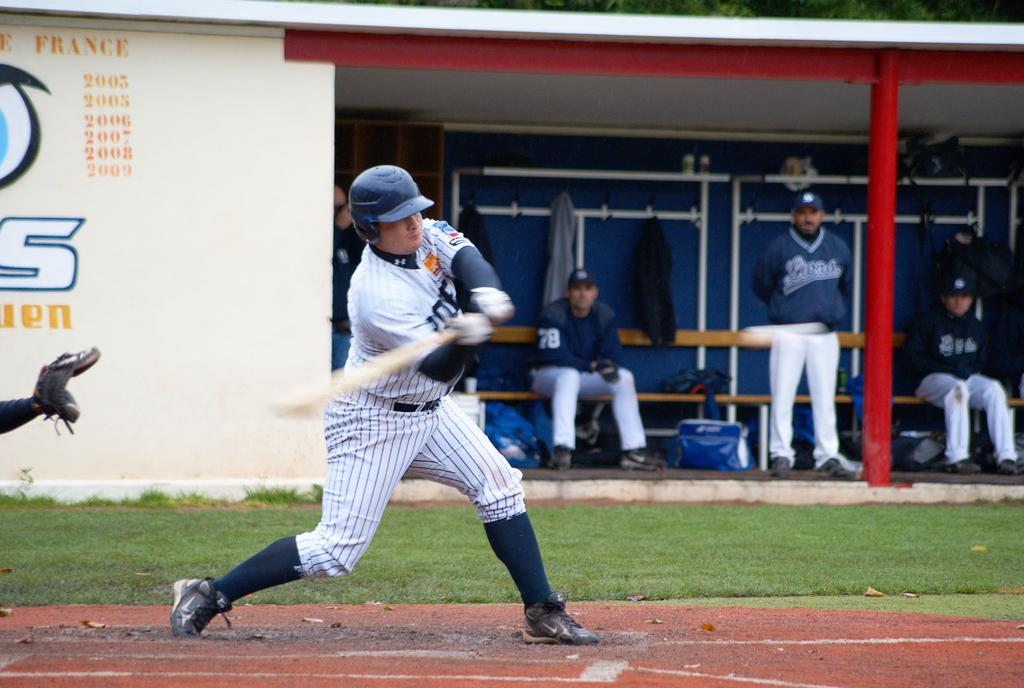<image>
Relay a brief, clear account of the picture shown. The word France is on the wall behind the batter 